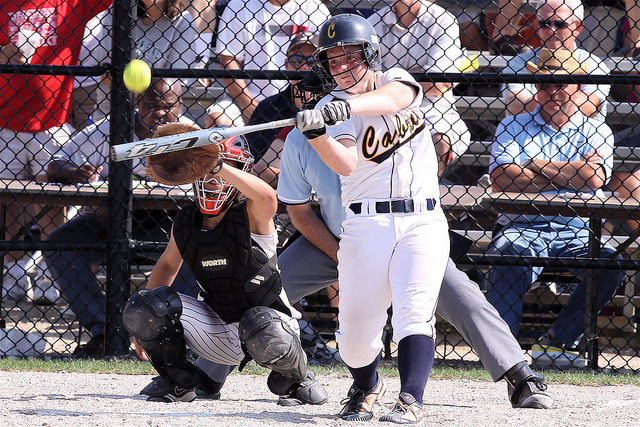Are there any spectators in the background? Yes, there are spectators visible in the background, seated behind the fence and watching the game, adding to the atmosphere of the event. 